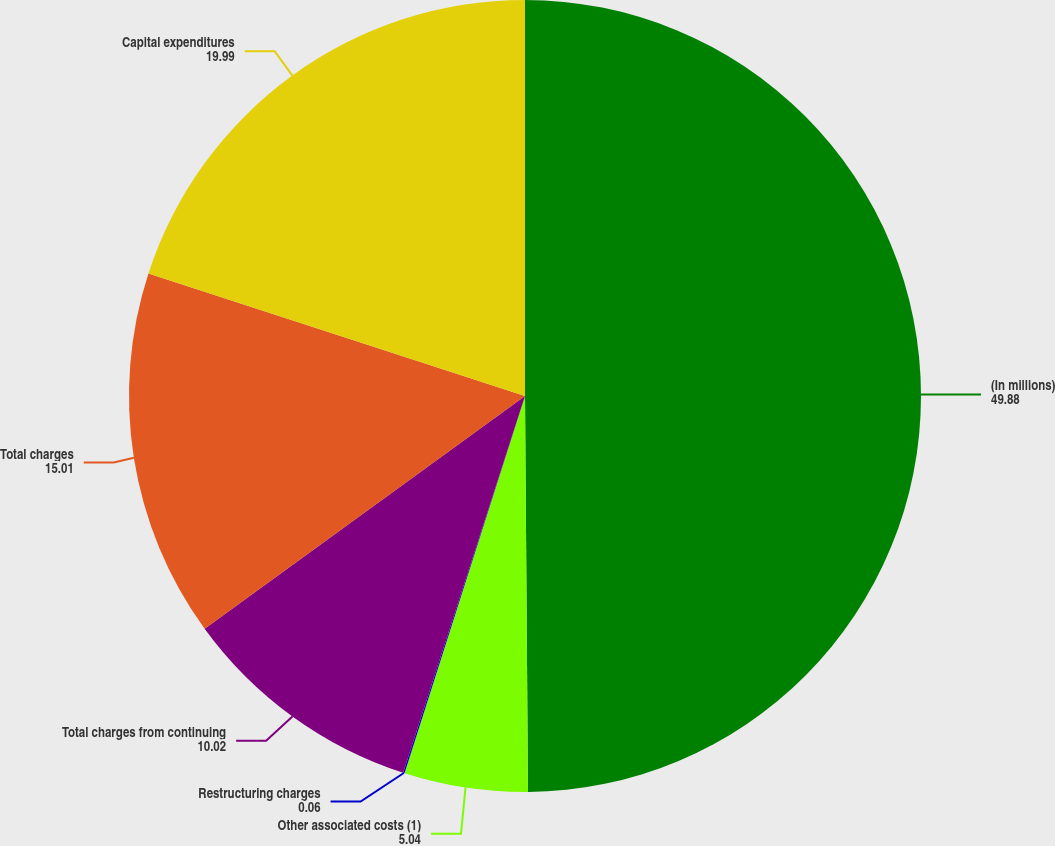<chart> <loc_0><loc_0><loc_500><loc_500><pie_chart><fcel>(In millions)<fcel>Other associated costs (1)<fcel>Restructuring charges<fcel>Total charges from continuing<fcel>Total charges<fcel>Capital expenditures<nl><fcel>49.88%<fcel>5.04%<fcel>0.06%<fcel>10.02%<fcel>15.01%<fcel>19.99%<nl></chart> 